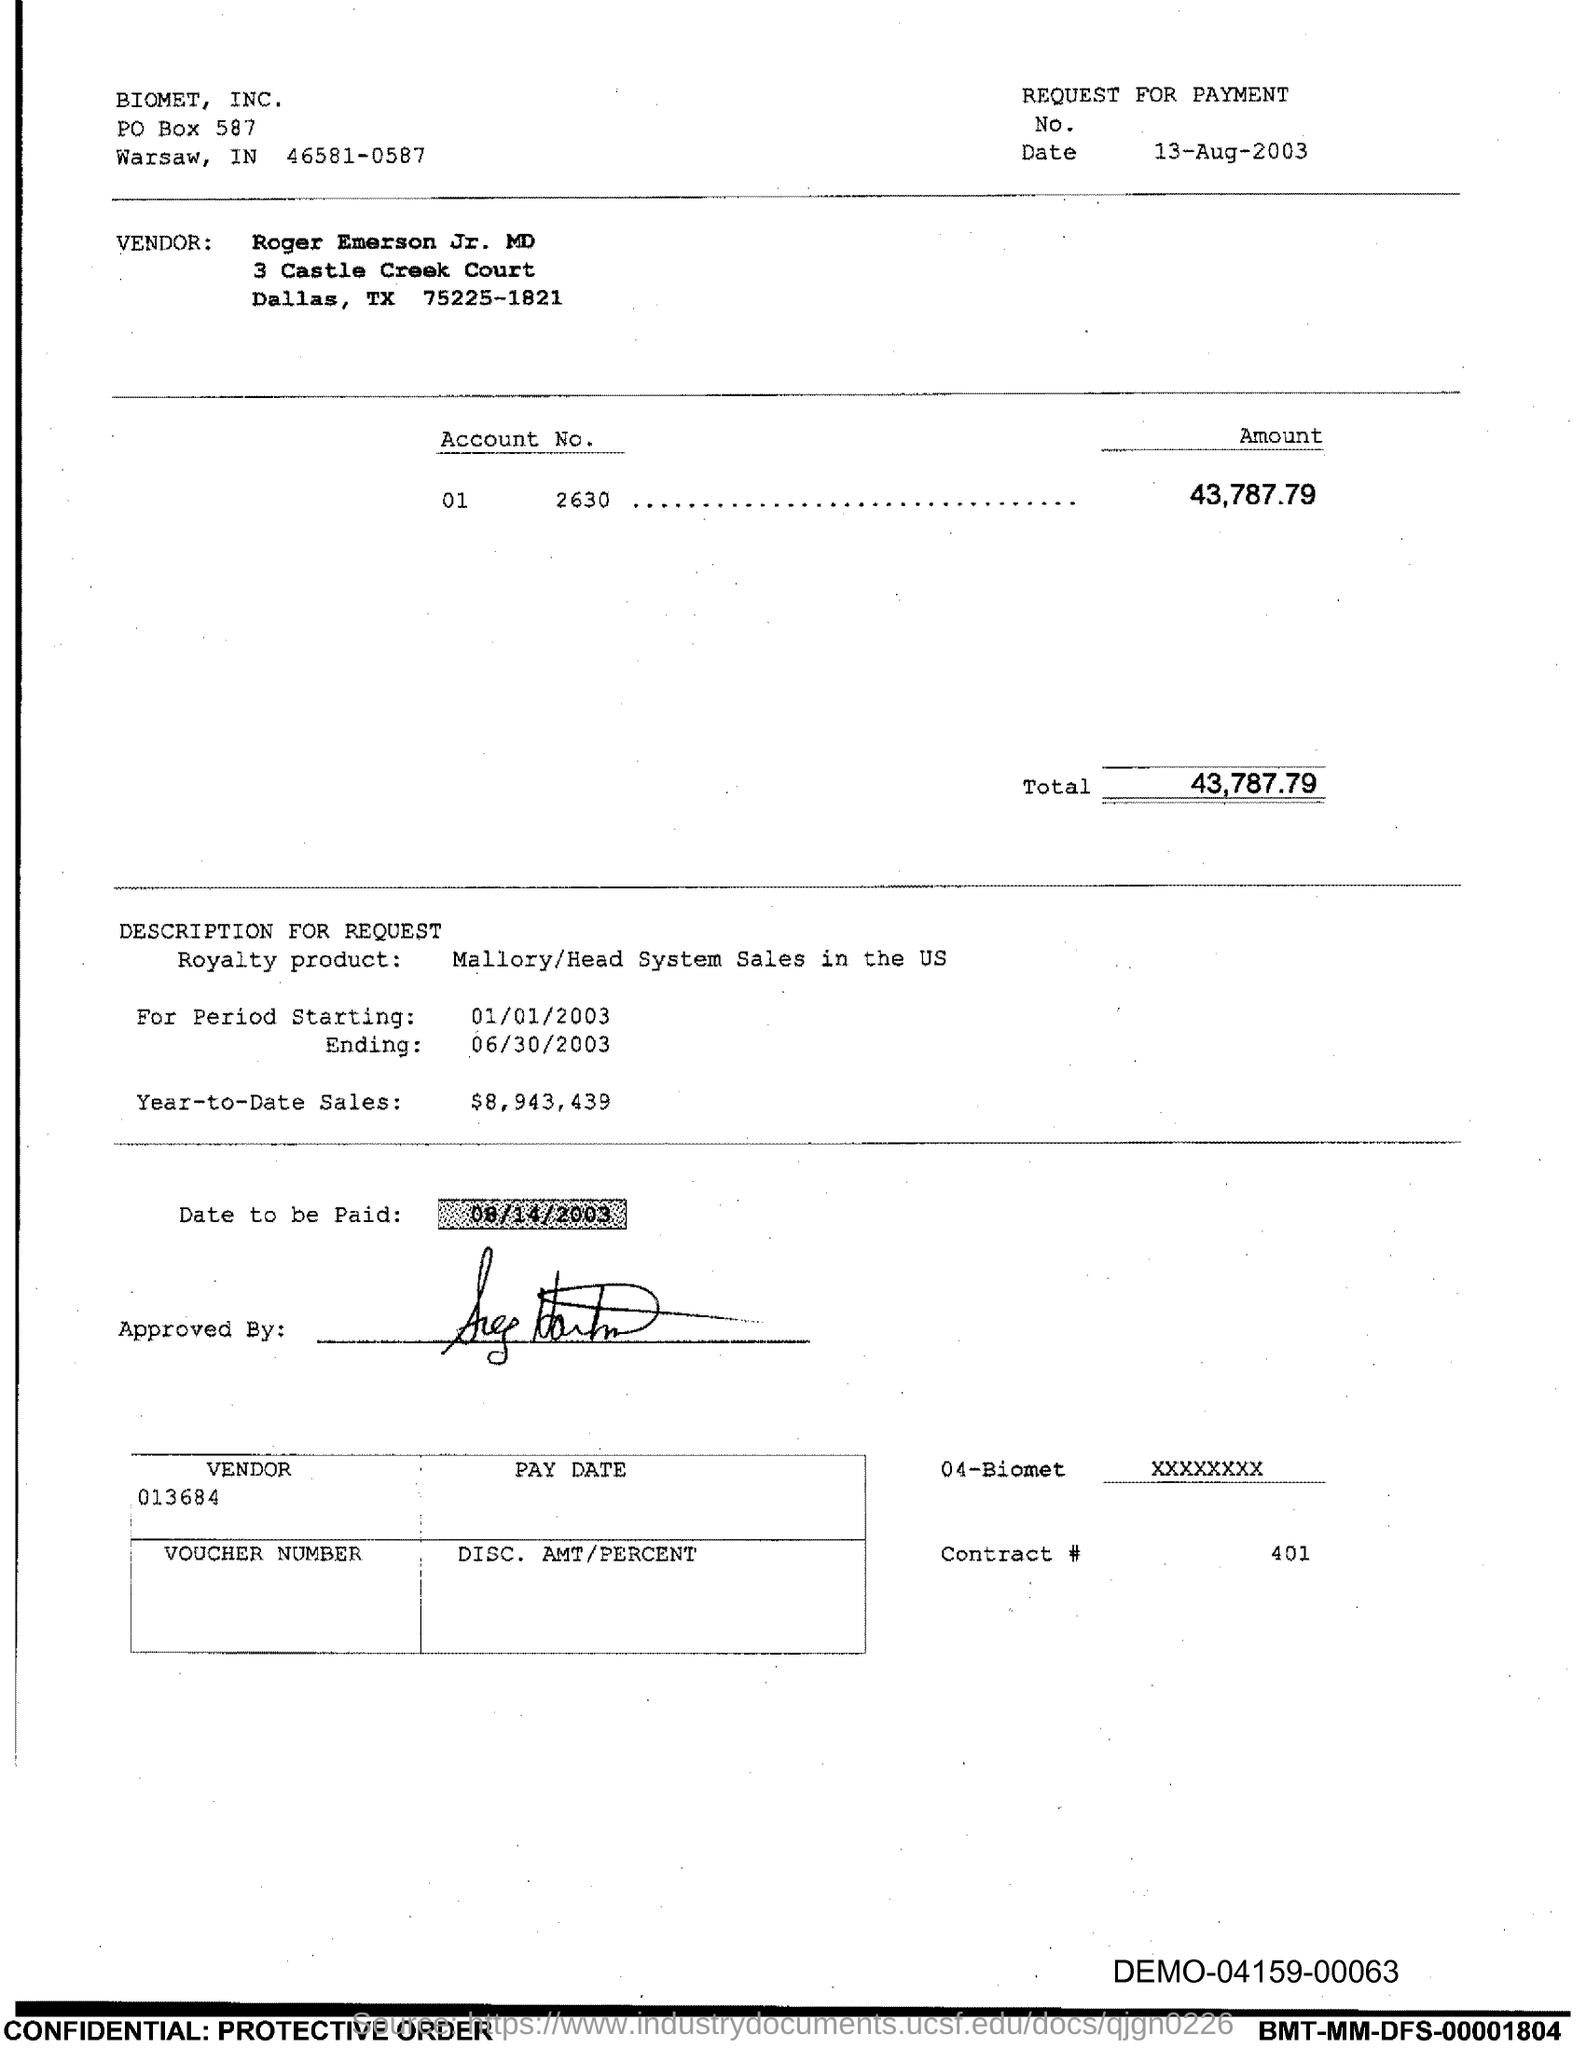Identify some key points in this picture. The date on which the payment is to be made, as indicated in the document, is August 14, 2003. The PO Box number mentioned in the document is 587. 